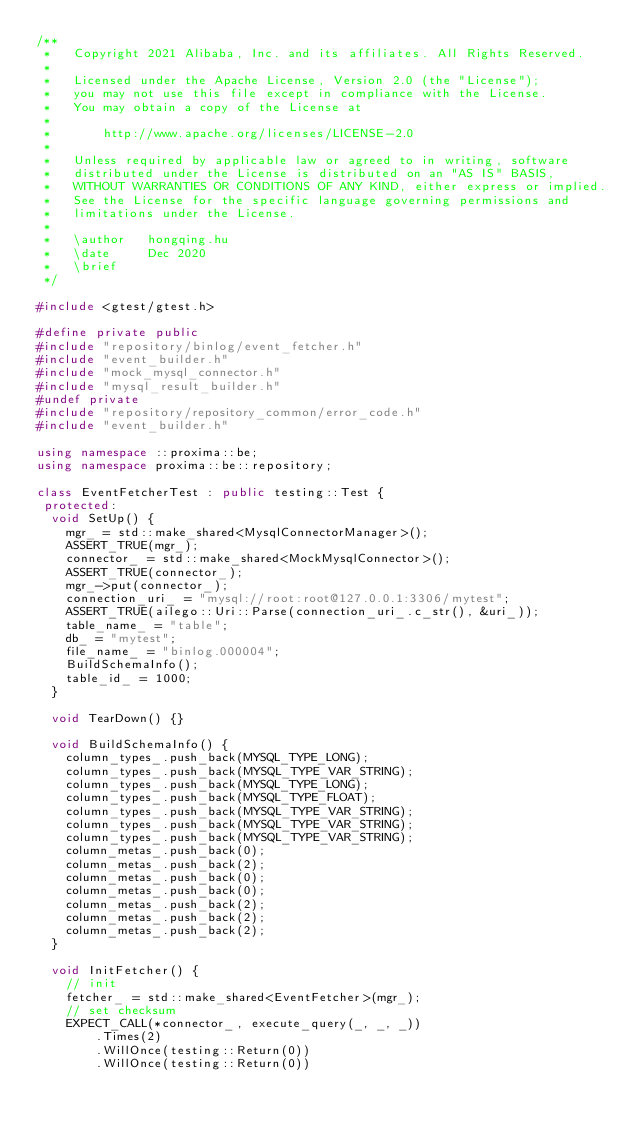Convert code to text. <code><loc_0><loc_0><loc_500><loc_500><_C++_>/**
 *   Copyright 2021 Alibaba, Inc. and its affiliates. All Rights Reserved.
 *
 *   Licensed under the Apache License, Version 2.0 (the "License");
 *   you may not use this file except in compliance with the License.
 *   You may obtain a copy of the License at
 *
 *       http://www.apache.org/licenses/LICENSE-2.0
 *
 *   Unless required by applicable law or agreed to in writing, software
 *   distributed under the License is distributed on an "AS IS" BASIS,
 *   WITHOUT WARRANTIES OR CONDITIONS OF ANY KIND, either express or implied.
 *   See the License for the specific language governing permissions and
 *   limitations under the License.
 *
 *   \author   hongqing.hu
 *   \date     Dec 2020
 *   \brief
 */

#include <gtest/gtest.h>

#define private public
#include "repository/binlog/event_fetcher.h"
#include "event_builder.h"
#include "mock_mysql_connector.h"
#include "mysql_result_builder.h"
#undef private
#include "repository/repository_common/error_code.h"
#include "event_builder.h"

using namespace ::proxima::be;
using namespace proxima::be::repository;

class EventFetcherTest : public testing::Test {
 protected:
  void SetUp() {
    mgr_ = std::make_shared<MysqlConnectorManager>();
    ASSERT_TRUE(mgr_);
    connector_ = std::make_shared<MockMysqlConnector>();
    ASSERT_TRUE(connector_);
    mgr_->put(connector_);
    connection_uri_ = "mysql://root:root@127.0.0.1:3306/mytest";
    ASSERT_TRUE(ailego::Uri::Parse(connection_uri_.c_str(), &uri_));
    table_name_ = "table";
    db_ = "mytest";
    file_name_ = "binlog.000004";
    BuildSchemaInfo();
    table_id_ = 1000;
  }

  void TearDown() {}

  void BuildSchemaInfo() {
    column_types_.push_back(MYSQL_TYPE_LONG);
    column_types_.push_back(MYSQL_TYPE_VAR_STRING);
    column_types_.push_back(MYSQL_TYPE_LONG);
    column_types_.push_back(MYSQL_TYPE_FLOAT);
    column_types_.push_back(MYSQL_TYPE_VAR_STRING);
    column_types_.push_back(MYSQL_TYPE_VAR_STRING);
    column_types_.push_back(MYSQL_TYPE_VAR_STRING);
    column_metas_.push_back(0);
    column_metas_.push_back(2);
    column_metas_.push_back(0);
    column_metas_.push_back(0);
    column_metas_.push_back(2);
    column_metas_.push_back(2);
    column_metas_.push_back(2);
  }

  void InitFetcher() {
    // init
    fetcher_ = std::make_shared<EventFetcher>(mgr_);
    // set checksum
    EXPECT_CALL(*connector_, execute_query(_, _, _))
        .Times(2)
        .WillOnce(testing::Return(0))
        .WillOnce(testing::Return(0))</code> 